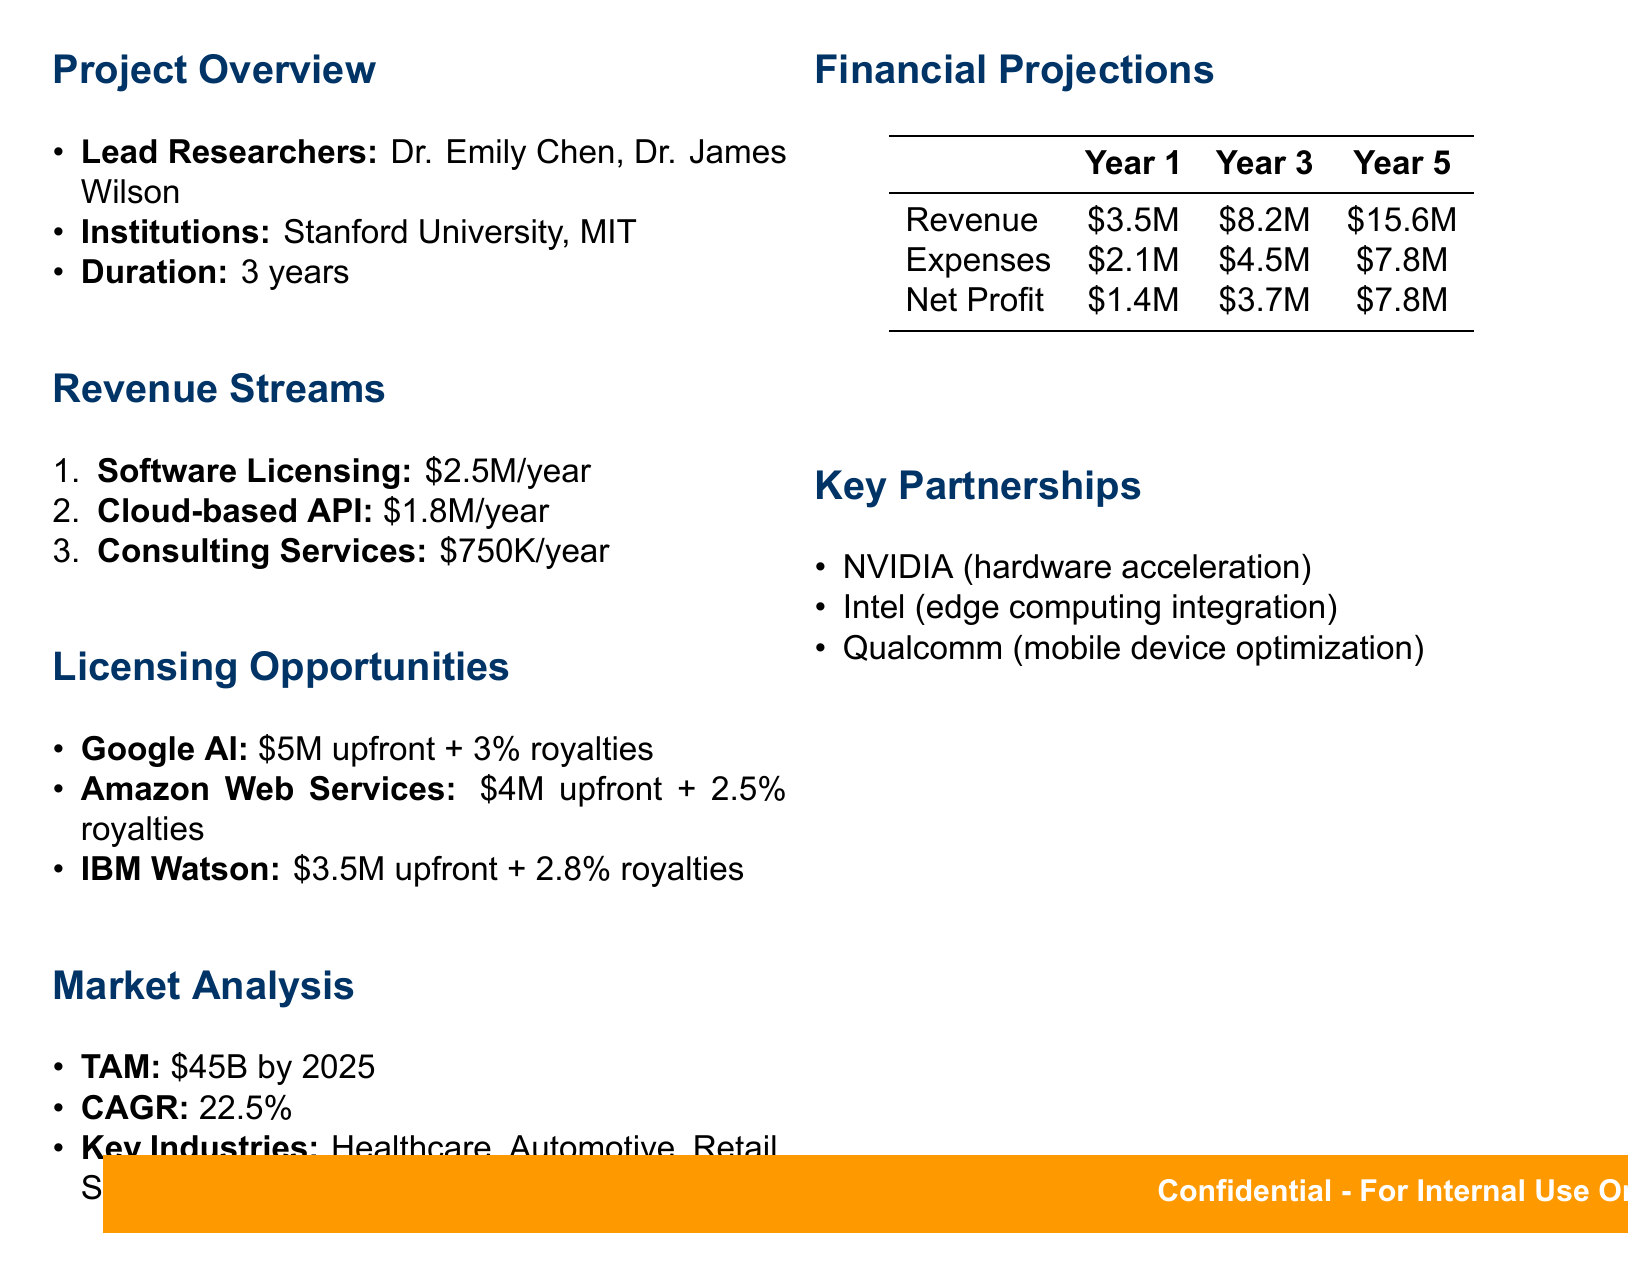What is the total addressable market by 2025? The total addressable market is specified in the market analysis section of the document.
Answer: $45 billion Who are the lead researchers? The names of the lead researchers are explicitly listed in the project overview.
Answer: Dr. Emily Chen, Dr. James Wilson What is the projected annual revenue from Software Licensing? The projected annual revenue from Software Licensing is detailed in the revenue streams section.
Answer: $2.5 million What are the financial projections for Year 3 net profit? The net profit for Year 3 is provided in the financial projections table.
Answer: $3.7 million Which company offers the largest potential deal? The potential deals for licensing opportunities can be found in the licensing opportunities section, which compares different companies.
Answer: Google AI What is the compound annual growth rate mentioned? The compound annual growth rate is noted in the market analysis section, indicating growth over time.
Answer: 22.5% What type of partnerships are emphasized in this report? The partnerships outlined in the document focus on companies involved in specific technological enhancements for the project.
Answer: Key Partnerships What is the projected revenue for Year 5? The projected revenue for Year 5 is listed in the financial projections table.
Answer: $15.6 million What services are included under Consulting Services? The description of Consulting Services is found in the revenue streams section, specifying what it entails.
Answer: Providing expert consulting for implementation 